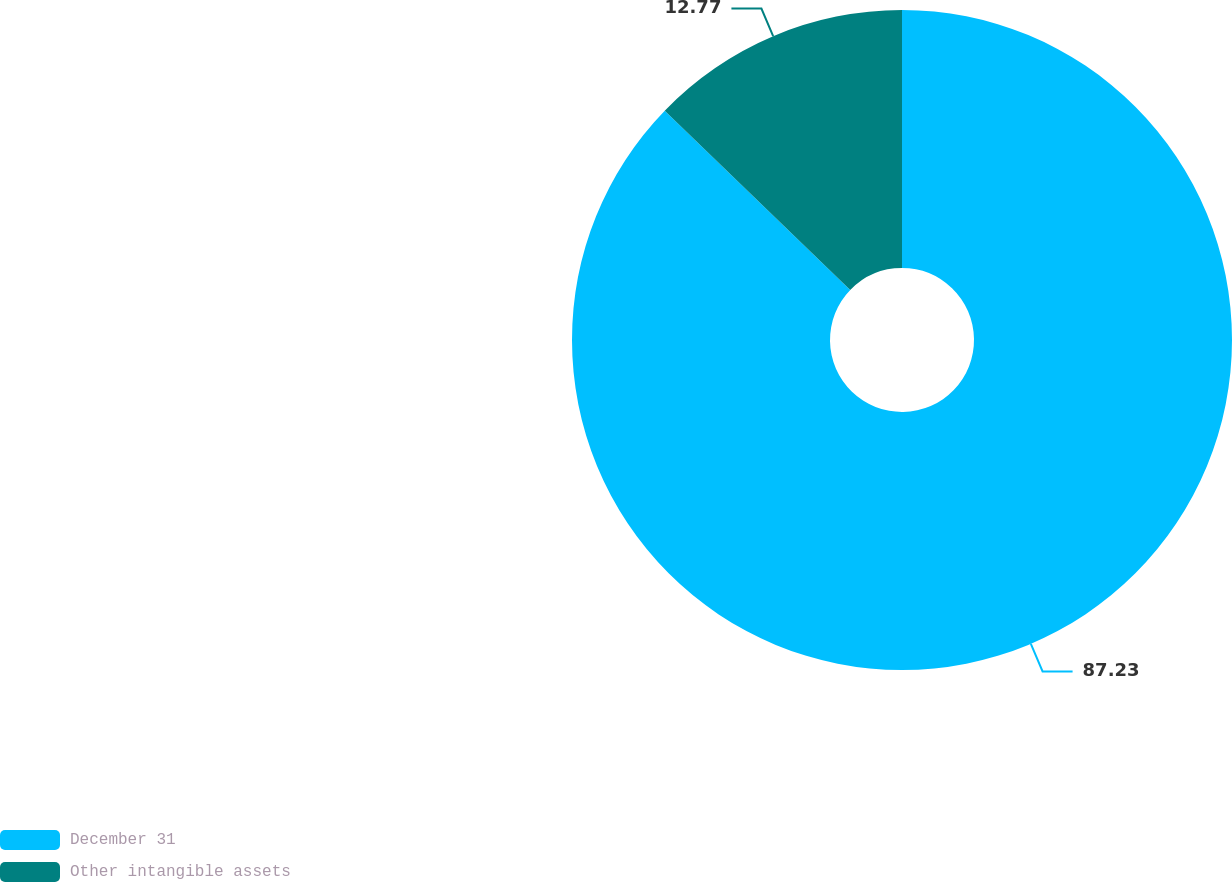Convert chart. <chart><loc_0><loc_0><loc_500><loc_500><pie_chart><fcel>December 31<fcel>Other intangible assets<nl><fcel>87.23%<fcel>12.77%<nl></chart> 